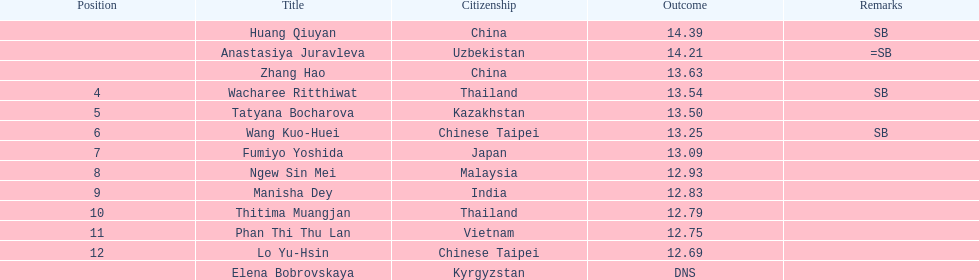I'm looking to parse the entire table for insights. Could you assist me with that? {'header': ['Position', 'Title', 'Citizenship', 'Outcome', 'Remarks'], 'rows': [['', 'Huang Qiuyan', 'China', '14.39', 'SB'], ['', 'Anastasiya Juravleva', 'Uzbekistan', '14.21', '=SB'], ['', 'Zhang Hao', 'China', '13.63', ''], ['4', 'Wacharee Ritthiwat', 'Thailand', '13.54', 'SB'], ['5', 'Tatyana Bocharova', 'Kazakhstan', '13.50', ''], ['6', 'Wang Kuo-Huei', 'Chinese Taipei', '13.25', 'SB'], ['7', 'Fumiyo Yoshida', 'Japan', '13.09', ''], ['8', 'Ngew Sin Mei', 'Malaysia', '12.93', ''], ['9', 'Manisha Dey', 'India', '12.83', ''], ['10', 'Thitima Muangjan', 'Thailand', '12.79', ''], ['11', 'Phan Thi Thu Lan', 'Vietnam', '12.75', ''], ['12', 'Lo Yu-Hsin', 'Chinese Taipei', '12.69', ''], ['', 'Elena Bobrovskaya', 'Kyrgyzstan', 'DNS', '']]} How long was manisha dey's jump? 12.83. 